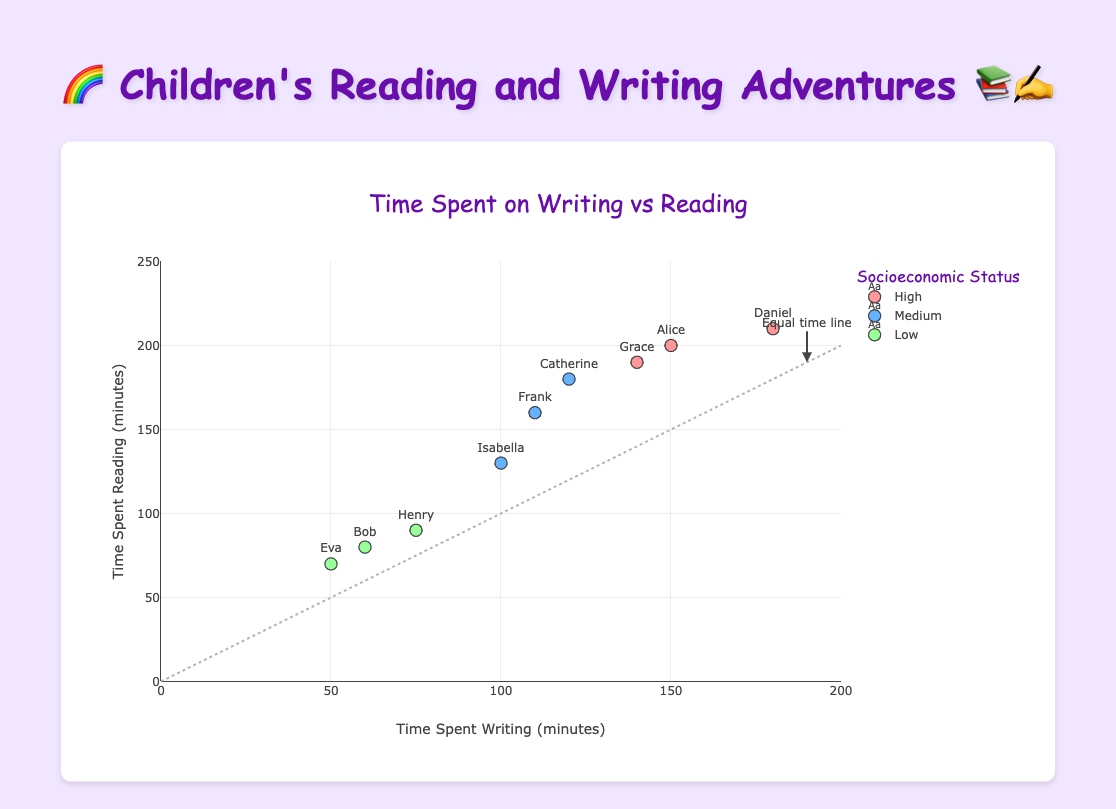What is the total time spent writing by children with high socioeconomic status? First, identify the data points with "High" socioeconomic status: Alice (150 minutes), Daniel (180 minutes), and Grace (140 minutes). Sum these amounts: 150 + 180 + 140
Answer: 470 minutes Who spent the least amount of time reading among the children, and what is their socioeconomic status? Look for the smallest reading time: Eva spent 70 minutes reading and has a "Low" socioeconomic status
Answer: Eva, Low How many children have a medium socioeconomic status? Count the number of data points with "Medium" socioeconomic status: Catherine, Frank, and Isabella
Answer: 3 children What does the diagonal dashed line represent in the plot? The dashed line represents the "Equal time line," where the time spent writing equals the time spent reading
Answer: Equal time line Which child spent the maximum time in writing activities, and how many minutes did they spend? Identify the child with the highest writing time: Daniel with 180 minutes
Answer: Daniel, 180 minutes Compare the reading times of the children named Catherine and Grace. Who spent more time reading and by how many minutes? Catherine spent 180 minutes, while Grace spent 190 minutes reading. Calculate the difference: 190 - 180
Answer: Grace, 10 minutes What is the average time spent reading by children with a low socioeconomic status? Sum the reading times of children with "Low" status: Bob (80), Eva (70), and Henry (90). Calculate the average: (80 + 70 + 90) / 3 = 240 / 3
Answer: 80 minutes How many children spent more time reading than writing? Compare the reading and writing times for each child: Alice, Catherine, Daniel, Grace, Henry, Isabella spent more time reading
Answer: 6 children Determine the range of time spent writing by children with a low socioeconomic status. Identify the writing times: Bob (60), Eva (50), and Henry (75). Find the range: 75 - 50
Answer: 25 minutes Which socioeconomic group has the data point farthest from the "Equal time line"? Find the point farthest from the line y=x. Daniel (180, 210) has the largest difference (210 - 180 = 30), belonging to the "High" group
Answer: High socioeconomic status 